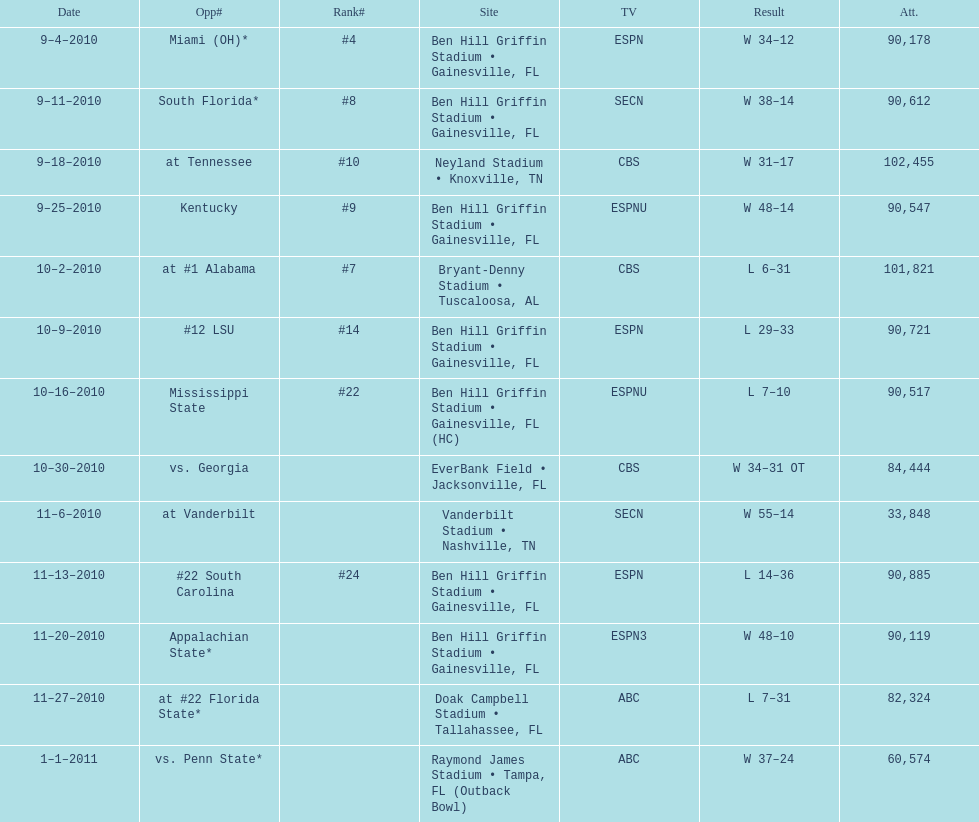What was the difference between the two scores of the last game? 13 points. 